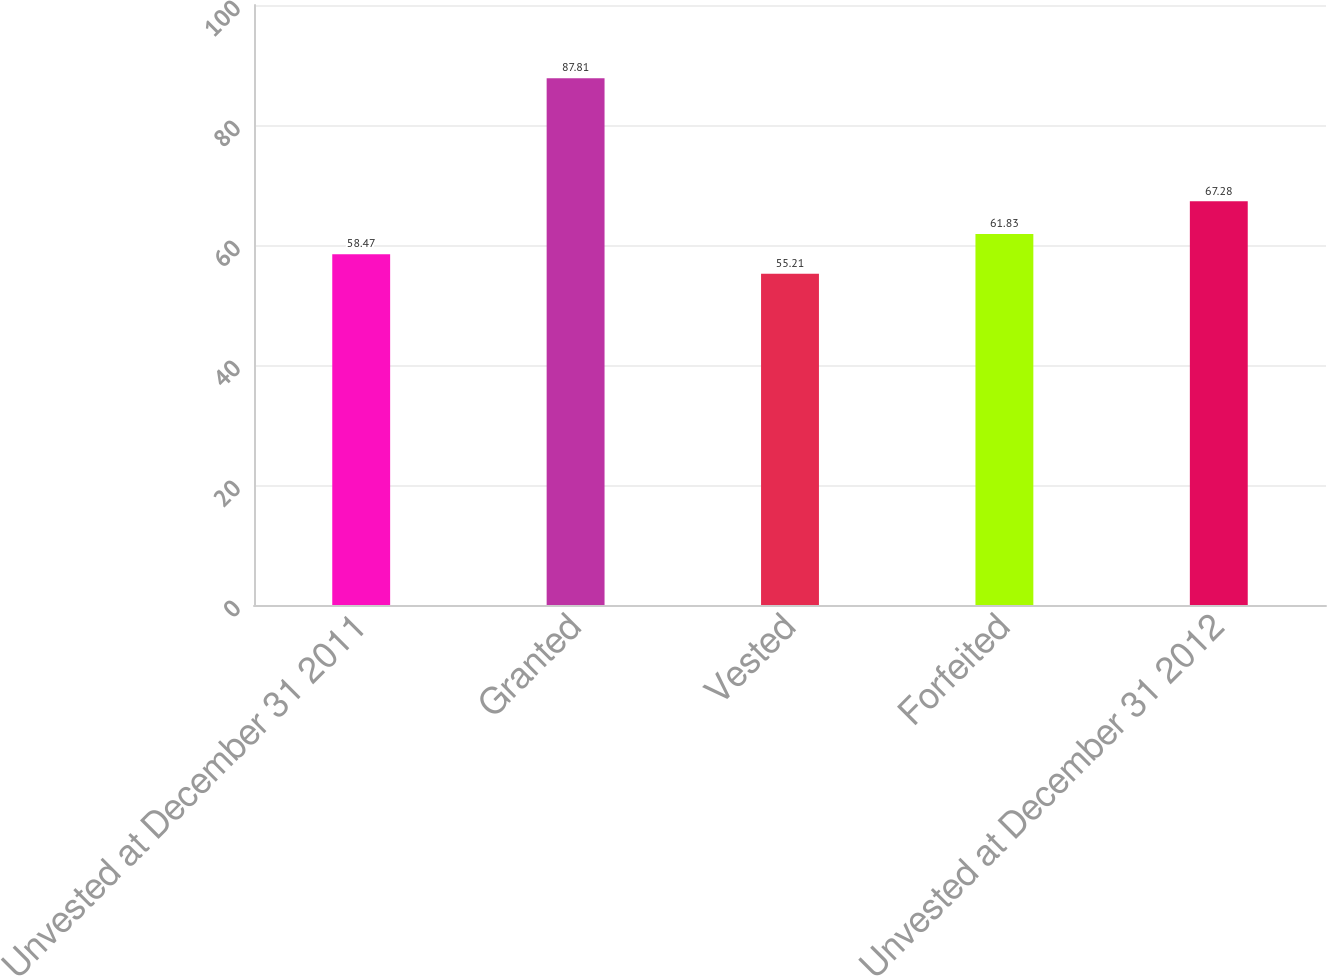Convert chart to OTSL. <chart><loc_0><loc_0><loc_500><loc_500><bar_chart><fcel>Unvested at December 31 2011<fcel>Granted<fcel>Vested<fcel>Forfeited<fcel>Unvested at December 31 2012<nl><fcel>58.47<fcel>87.81<fcel>55.21<fcel>61.83<fcel>67.28<nl></chart> 